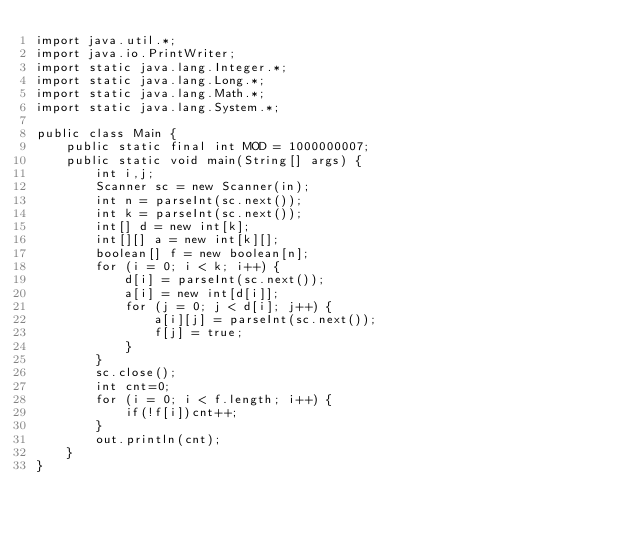Convert code to text. <code><loc_0><loc_0><loc_500><loc_500><_Java_>import java.util.*;
import java.io.PrintWriter;
import static java.lang.Integer.*;
import static java.lang.Long.*;
import static java.lang.Math.*;
import static java.lang.System.*;

public class Main {
	public static final int MOD = 1000000007;
	public static void main(String[] args) {
		int i,j;
		Scanner sc = new Scanner(in);
		int n = parseInt(sc.next());
		int k = parseInt(sc.next());
		int[] d = new int[k];
		int[][] a = new int[k][];
		boolean[] f = new boolean[n];
		for (i = 0; i < k; i++) {
			d[i] = parseInt(sc.next());
			a[i] = new int[d[i]];
			for (j = 0; j < d[i]; j++) {
				a[i][j] = parseInt(sc.next());
				f[j] = true;
			}
		}
		sc.close();
		int cnt=0;
		for (i = 0; i < f.length; i++) {
			if(!f[i])cnt++;
		}
		out.println(cnt);
	}
}
</code> 